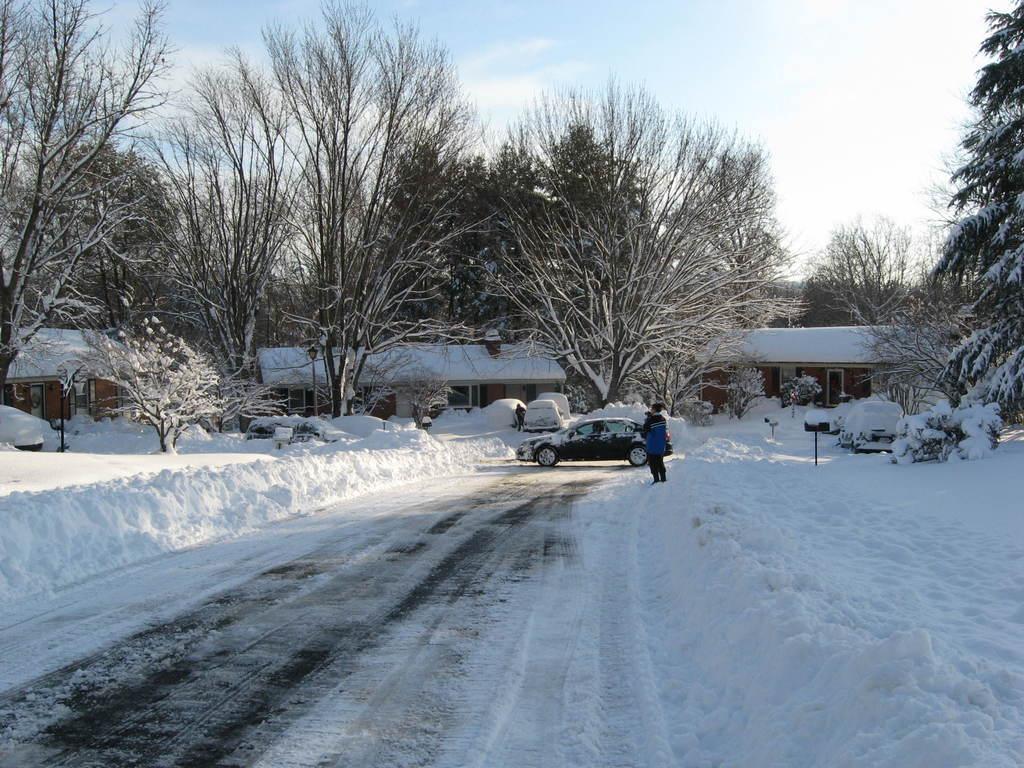How would you summarize this image in a sentence or two? In this image I can see the snow. I can see the vehicles. I can see a person standing. In the background, I can see the trees and clouds in the sky. 